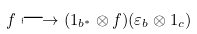<formula> <loc_0><loc_0><loc_500><loc_500>f \longmapsto ( 1 _ { b ^ { \ast } } \otimes f ) ( \varepsilon _ { b } \otimes 1 _ { c } )</formula> 